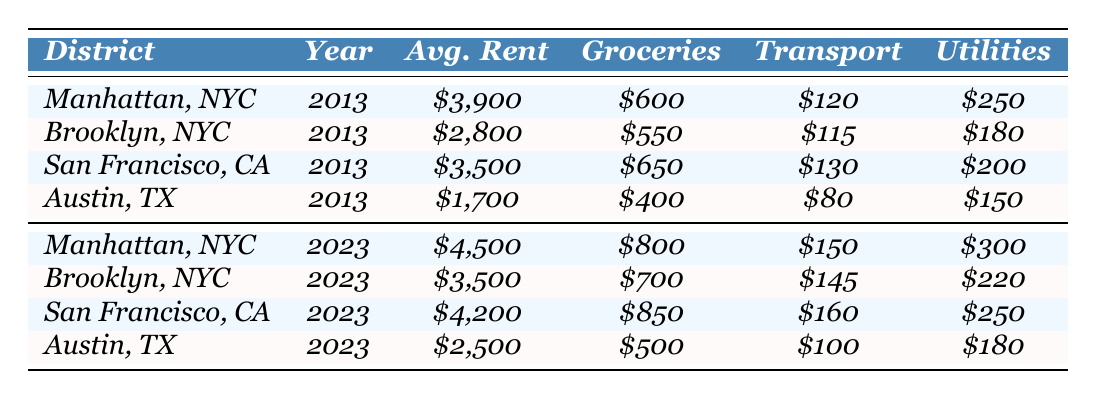What is the average rent in Manhattan in 2023? The table shows that the average rent in Manhattan for the year 2023 is listed as $4,500.
Answer: $4,500 Which district had the lowest average rent in 2013? By comparing the average rents in 2013, Austin, Texas shows the lowest average rent at $1,700.
Answer: Austin, Texas What is the total cost of groceries and utilities in Brooklyn in 2023? For Brooklyn in 2023, groceries are $700 and utilities are $220. Adding these gives $700 + $220 = $920.
Answer: $920 Did the average cost of living increase in Manhattan from 2013 to 2023? Comparing the average rent and costs in both years for Manhattan, all categories show an increase: rent goes from $3,900 to $4,500, groceries from $600 to $800, transportation from $120 to $150, and utilities from $250 to $300. Therefore, the cost of living increased.
Answer: Yes What is the difference in average rent between San Francisco in 2023 and Austin in 2023? The average rent in San Francisco in 2023 is $4,200, and in Austin, it is $2,500. The difference is $4,200 - $2,500 = $1,700.
Answer: $1,700 Which district experienced the largest increase in average rent from 2013 to 2023? The rent for Manhattan increased from $3,900 to $4,500 (a difference of $600), Brooklyn increased from $2,800 to $3,500 (a difference of $700), San Francisco increased from $3,500 to $4,200 (a difference of $700), and Austin increased from $1,700 to $2,500 (a difference of $800). Thus, Austin had the largest increase.
Answer: Austin What was the average transportation cost in Brooklyn over the decade? In 2013, the transportation cost in Brooklyn was $115, and in 2023 it was $145. Averaging these two values gives ($115 + $145) / 2 = $130.
Answer: $130 Is the average utility cost higher in 2023 for any district compared to 2013? For 2023, utilities are $300 in Manhattan (up from $250), $220 in Brooklyn (up from $180), $250 in San Francisco (up from $200), and $180 in Austin (up from $150). All districts show a higher utility cost in 2023 compared to 2013.
Answer: Yes What is the average cost of groceries in San Francisco over the decade? Groceries in San Francisco were $650 in 2013 and $850 in 2023. The average is ($650 + $850) / 2 = $750.
Answer: $750 Is the average transportation cost in Austin lower in 2023 than the average transportation cost in Manhattan in 2013? The average transportation cost in Austin in 2023 is $100, while in Manhattan in 2013, it was $120. Since $100 is less than $120, Austin's transportation cost in 2023 is indeed lower.
Answer: Yes 